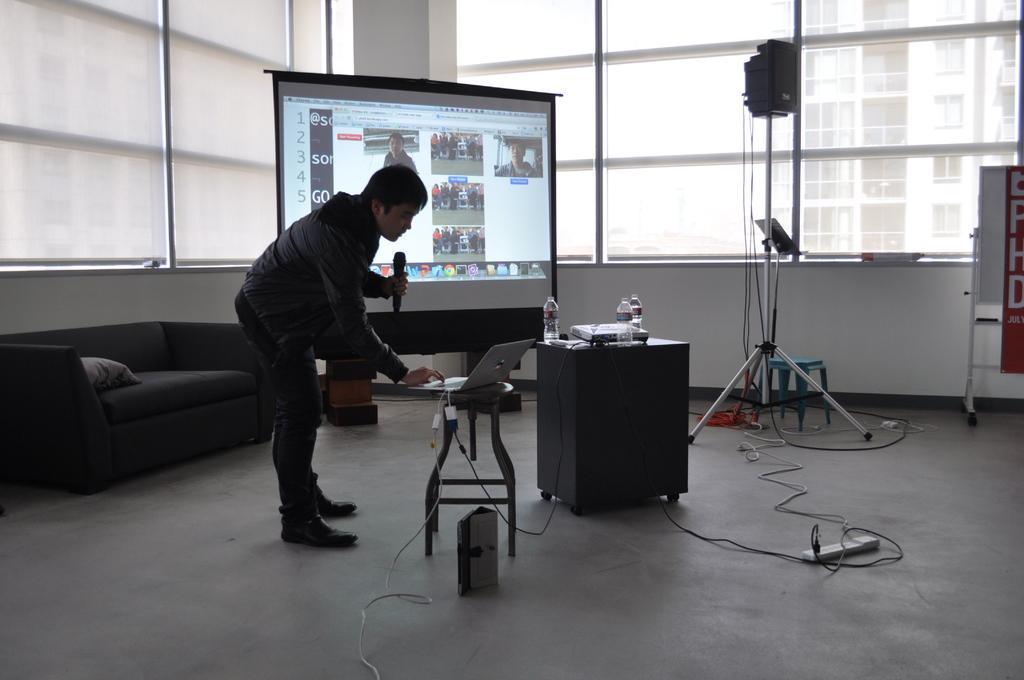In one or two sentences, can you explain what this image depicts? In this image I see a man who is holding the mic and the other hand is on a laptop and it is on the stool, I can also there is a table on which there 3 bottles. In the background I see the screen, windows and the sofa. 